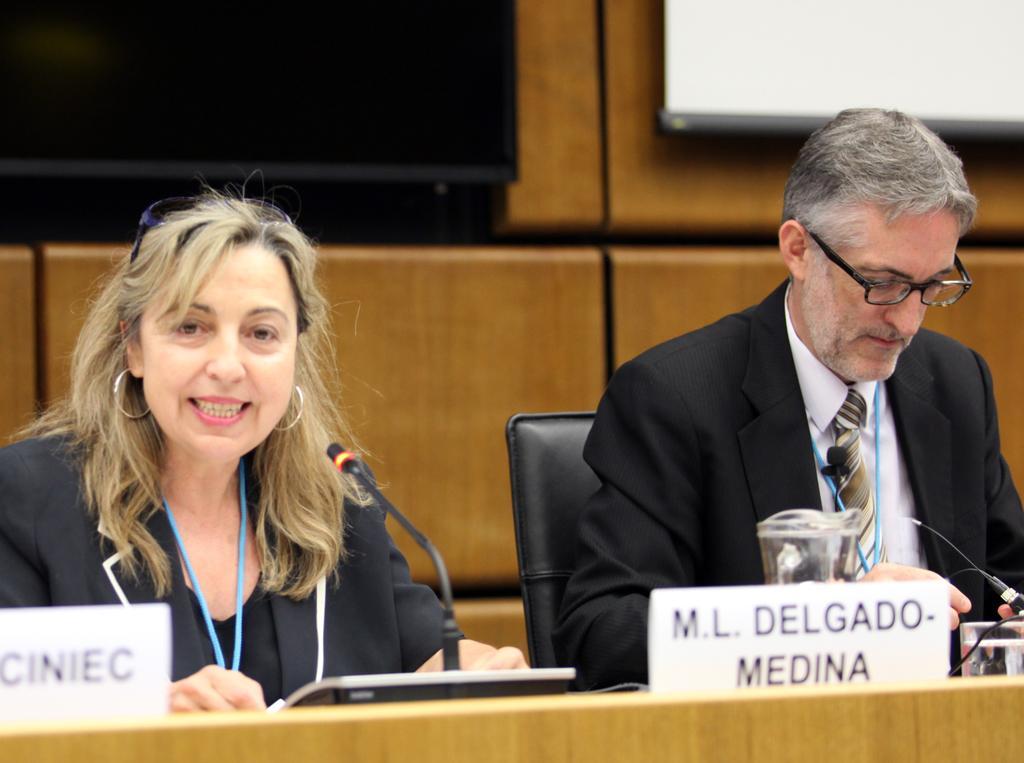How would you summarize this image in a sentence or two? In this image I see man and a woman who are sitting on chairs and I see that there are mice and name boards on this table and I see a glass over here and I see that both of them are wearing black color suit. In the background I see the black screen over here and I see the white color thing over here and I see the wall. 